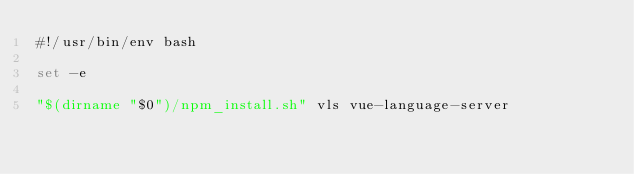<code> <loc_0><loc_0><loc_500><loc_500><_Bash_>#!/usr/bin/env bash

set -e

"$(dirname "$0")/npm_install.sh" vls vue-language-server
</code> 